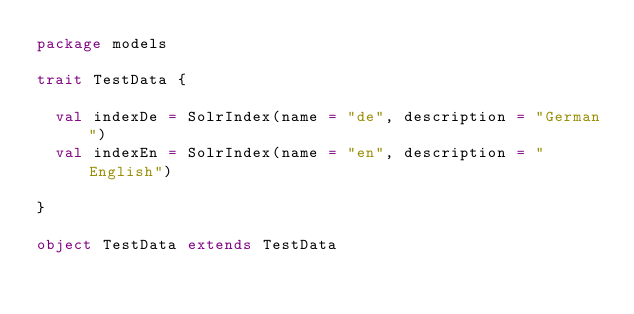<code> <loc_0><loc_0><loc_500><loc_500><_Scala_>package models

trait TestData {

  val indexDe = SolrIndex(name = "de", description = "German")
  val indexEn = SolrIndex(name = "en", description = "English")

}

object TestData extends TestData
</code> 